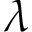<formula> <loc_0><loc_0><loc_500><loc_500>\lambda</formula> 